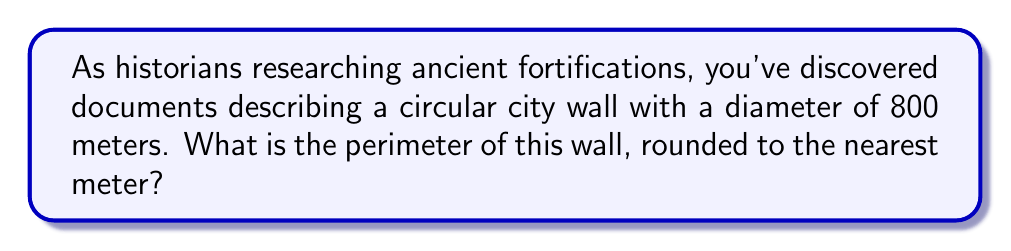Can you solve this math problem? To solve this problem, we'll follow these steps:

1) The formula for the circumference (perimeter) of a circle is:

   $$C = \pi d$$

   where $C$ is the circumference, $\pi$ is pi, and $d$ is the diameter.

2) We're given that the diameter is 800 meters. Let's substitute this into our formula:

   $$C = \pi \cdot 800$$

3) We can use 3.14159 as an approximation for $\pi$:

   $$C = 3.14159 \cdot 800$$

4) Now, let's calculate:

   $$C = 2513.272 \text{ meters}$$

5) Rounding to the nearest meter as requested:

   $$C \approx 2513 \text{ meters}$$

[asy]
unitsize(0.1cm);
draw(circle((0,0),40), black+1);
draw((0,-40)--(0,40), dashed);
label("800 m", (0,-45));
label("Circular City Wall", (0,45));
[/asy]
Answer: 2513 meters 